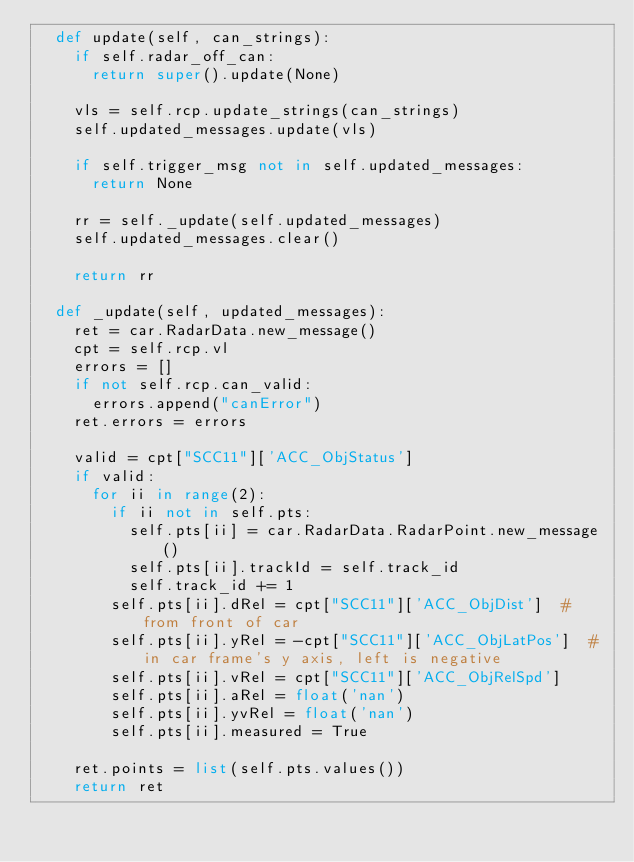Convert code to text. <code><loc_0><loc_0><loc_500><loc_500><_Python_>  def update(self, can_strings):
    if self.radar_off_can:
      return super().update(None)

    vls = self.rcp.update_strings(can_strings)
    self.updated_messages.update(vls)

    if self.trigger_msg not in self.updated_messages:
      return None

    rr = self._update(self.updated_messages)
    self.updated_messages.clear()

    return rr

  def _update(self, updated_messages):
    ret = car.RadarData.new_message()
    cpt = self.rcp.vl
    errors = []
    if not self.rcp.can_valid:
      errors.append("canError")
    ret.errors = errors

    valid = cpt["SCC11"]['ACC_ObjStatus']
    if valid:
      for ii in range(2):
        if ii not in self.pts:
          self.pts[ii] = car.RadarData.RadarPoint.new_message()
          self.pts[ii].trackId = self.track_id
          self.track_id += 1
        self.pts[ii].dRel = cpt["SCC11"]['ACC_ObjDist']  # from front of car
        self.pts[ii].yRel = -cpt["SCC11"]['ACC_ObjLatPos']  # in car frame's y axis, left is negative
        self.pts[ii].vRel = cpt["SCC11"]['ACC_ObjRelSpd']
        self.pts[ii].aRel = float('nan')
        self.pts[ii].yvRel = float('nan')
        self.pts[ii].measured = True

    ret.points = list(self.pts.values())
    return ret
</code> 